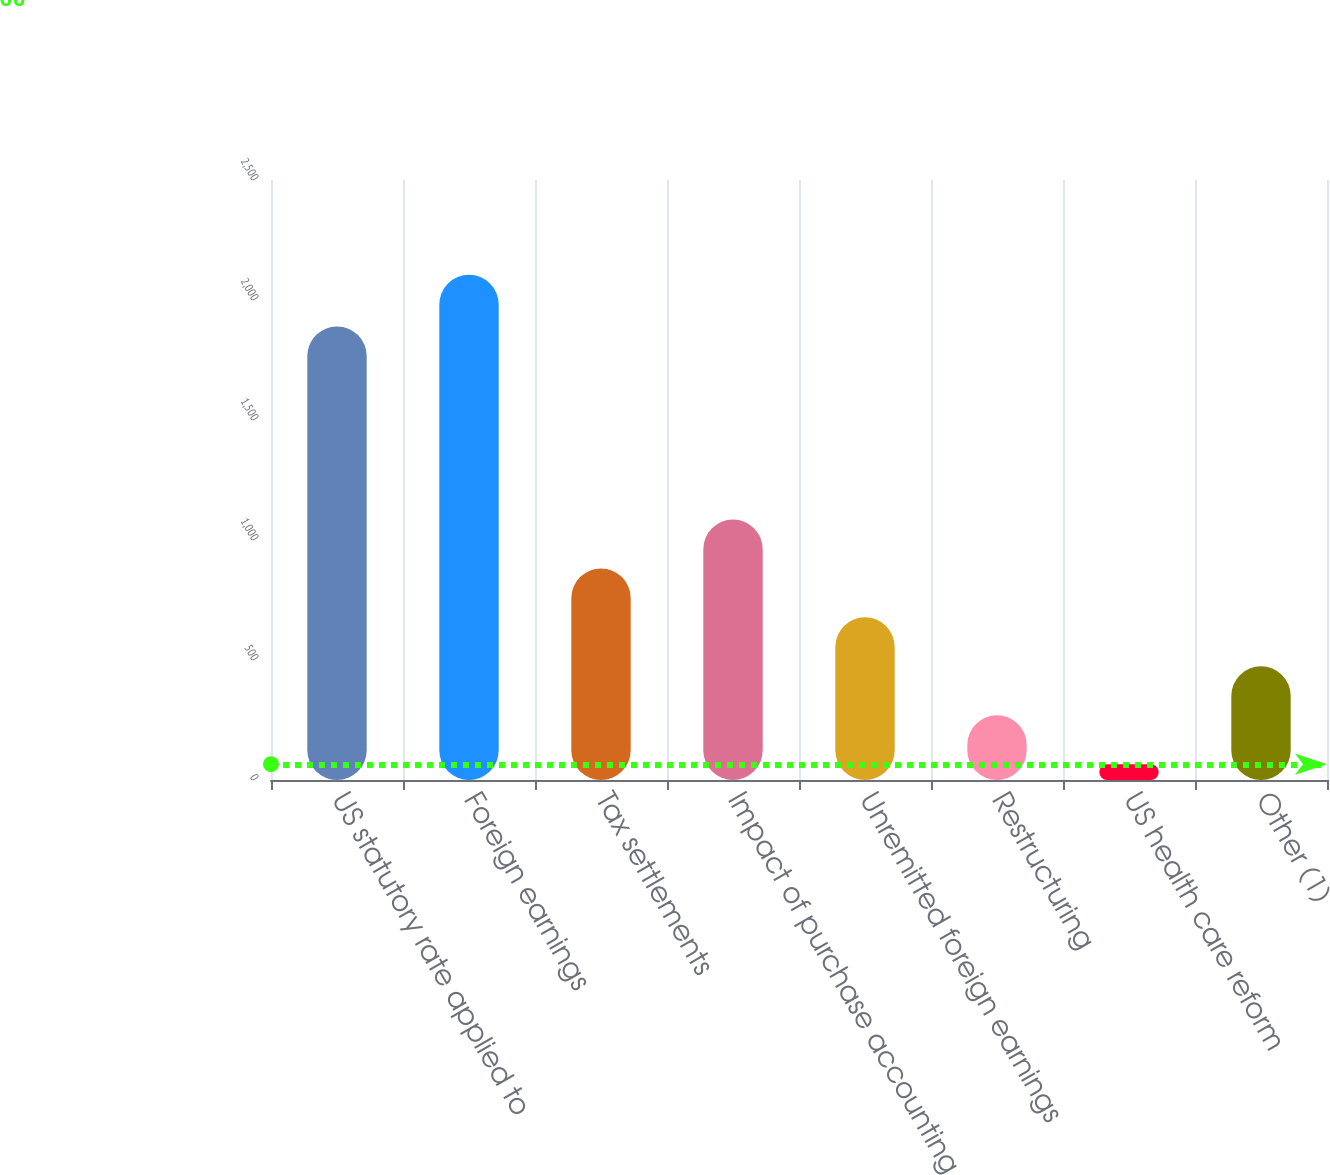Convert chart. <chart><loc_0><loc_0><loc_500><loc_500><bar_chart><fcel>US statutory rate applied to<fcel>Foreign earnings<fcel>Tax settlements<fcel>Impact of purchase accounting<fcel>Unremitted foreign earnings<fcel>Restructuring<fcel>US health care reform<fcel>Other (1)<nl><fcel>1890<fcel>2105<fcel>881.6<fcel>1085.5<fcel>677.7<fcel>269.9<fcel>66<fcel>473.8<nl></chart> 